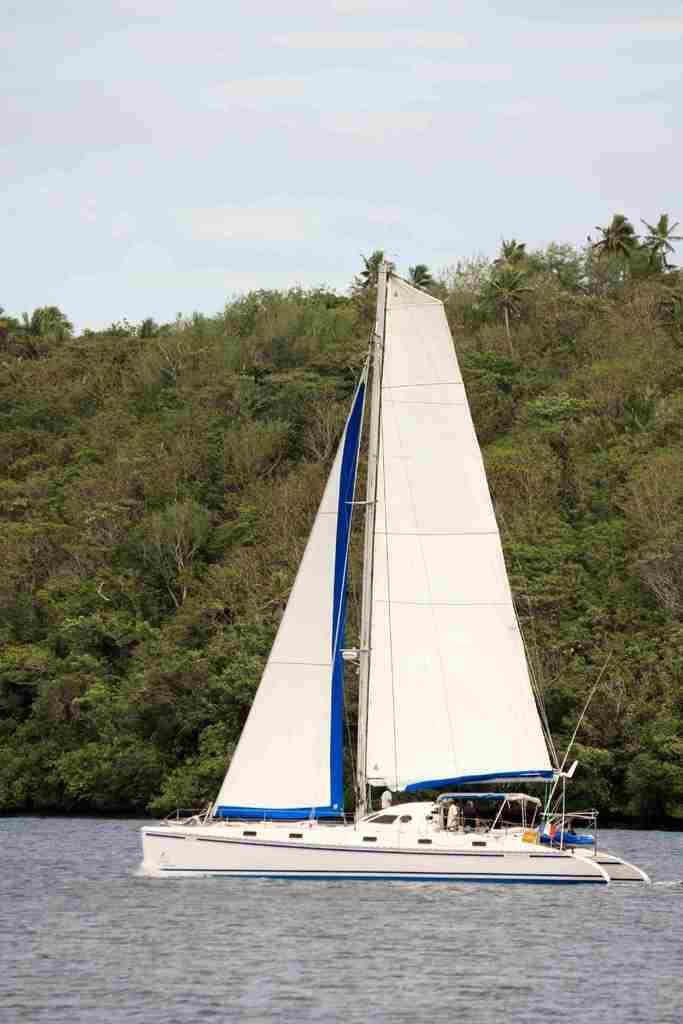Could you give a brief overview of what you see in this image? In the picture I can see a white color boat on the water. In the background I can see trees and the sky. On the boat I can see a person and some other objects. 